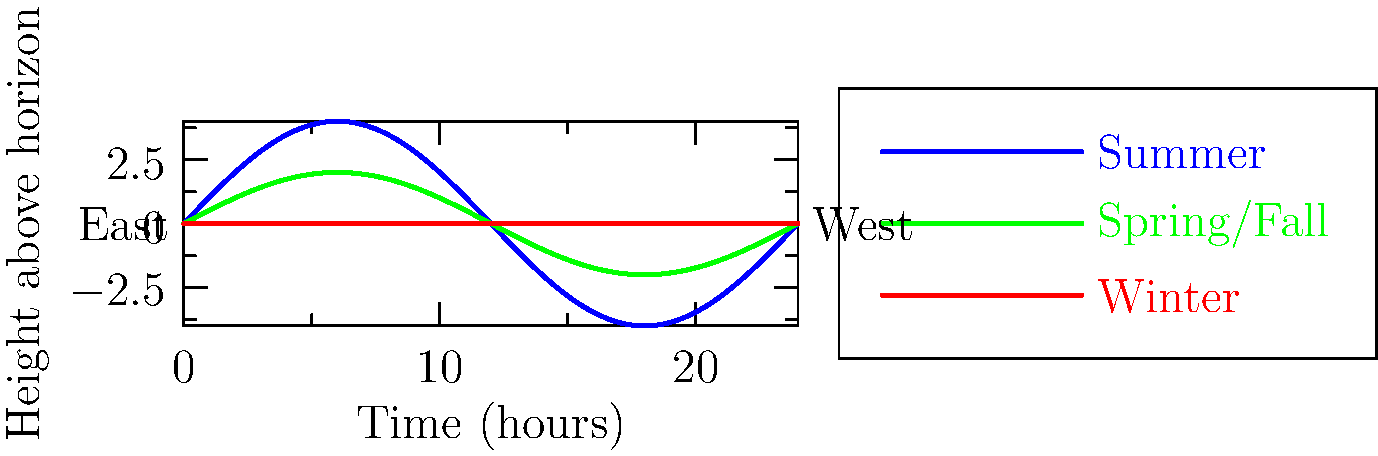How does the sun's path across the sky differ between summer and winter, and why is this knowledge important for navigation at sea? 1. Summer path (blue line):
   - The sun rises earlier and sets later
   - It reaches a higher point in the sky at noon
   - This creates a longer, higher arc across the sky

2. Winter path (red line):
   - The sun rises later and sets earlier
   - It stays lower in the sky throughout the day
   - This creates a shorter, lower arc across the sky

3. Spring/Fall path (green line):
   - Represents the equinoxes, when day and night are equal
   - The sun's path is between the summer and winter extremes

4. Importance for navigation:
   - Knowing the sun's path helps determine latitude
   - It aids in estimating time of day without a clock
   - Understanding seasonal changes assists in long-term voyage planning

5. Traditional maritime knowledge:
   - Fishermen use the sun's position to navigate back to shore
   - The sun's path helps predict weather patterns and fish behavior
   - This knowledge is crucial for safety and successful fishing expeditions

6. Respect for the ocean:
   - Understanding celestial movements fosters a deeper connection with nature
   - It emphasizes the importance of preserving traditional maritime knowledge
   - This wisdom highlights the interconnectedness of celestial and marine ecosystems
Answer: The sun's path is higher and longer in summer, lower and shorter in winter; essential for navigation, timing, and respecting nature's cycles. 